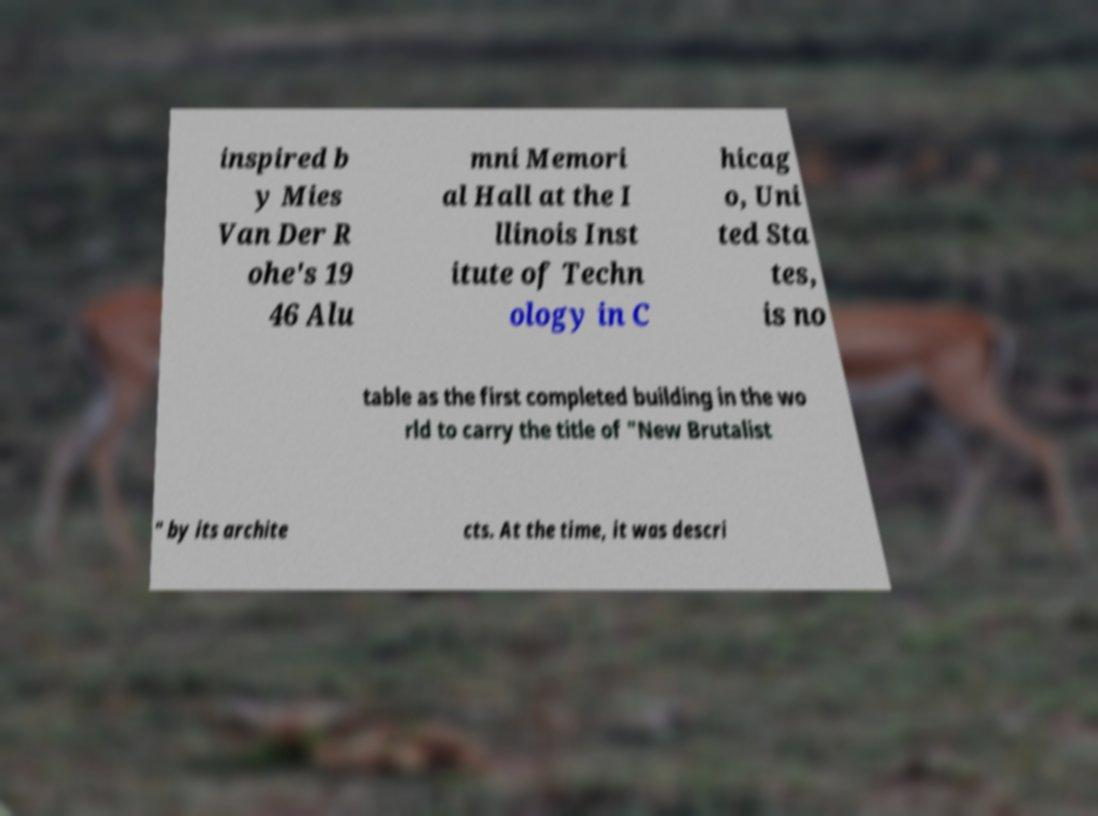Can you accurately transcribe the text from the provided image for me? inspired b y Mies Van Der R ohe's 19 46 Alu mni Memori al Hall at the I llinois Inst itute of Techn ology in C hicag o, Uni ted Sta tes, is no table as the first completed building in the wo rld to carry the title of "New Brutalist " by its archite cts. At the time, it was descri 